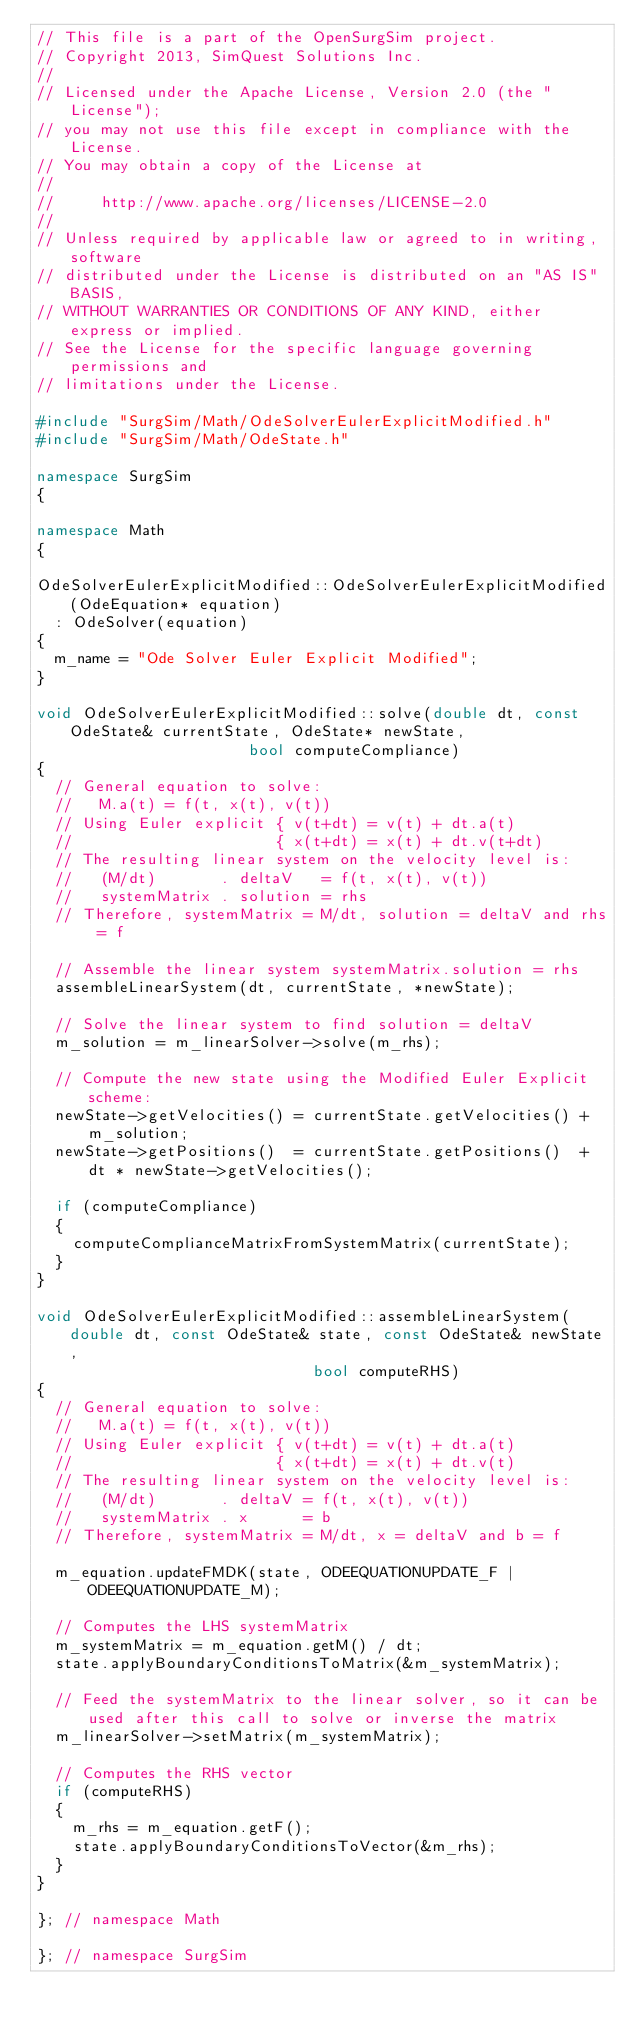<code> <loc_0><loc_0><loc_500><loc_500><_C++_>// This file is a part of the OpenSurgSim project.
// Copyright 2013, SimQuest Solutions Inc.
//
// Licensed under the Apache License, Version 2.0 (the "License");
// you may not use this file except in compliance with the License.
// You may obtain a copy of the License at
//
//     http://www.apache.org/licenses/LICENSE-2.0
//
// Unless required by applicable law or agreed to in writing, software
// distributed under the License is distributed on an "AS IS" BASIS,
// WITHOUT WARRANTIES OR CONDITIONS OF ANY KIND, either express or implied.
// See the License for the specific language governing permissions and
// limitations under the License.

#include "SurgSim/Math/OdeSolverEulerExplicitModified.h"
#include "SurgSim/Math/OdeState.h"

namespace SurgSim
{

namespace Math
{

OdeSolverEulerExplicitModified::OdeSolverEulerExplicitModified(OdeEquation* equation)
	: OdeSolver(equation)
{
	m_name = "Ode Solver Euler Explicit Modified";
}

void OdeSolverEulerExplicitModified::solve(double dt, const OdeState& currentState, OdeState* newState,
										   bool computeCompliance)
{
	// General equation to solve:
	//   M.a(t) = f(t, x(t), v(t))
	// Using Euler explicit { v(t+dt) = v(t) + dt.a(t)
	//                      { x(t+dt) = x(t) + dt.v(t+dt)
	// The resulting linear system on the velocity level is:
	//   (M/dt)       . deltaV   = f(t, x(t), v(t))
	//   systemMatrix . solution = rhs
	// Therefore, systemMatrix = M/dt, solution = deltaV and rhs = f

	// Assemble the linear system systemMatrix.solution = rhs
	assembleLinearSystem(dt, currentState, *newState);

	// Solve the linear system to find solution = deltaV
	m_solution = m_linearSolver->solve(m_rhs);

	// Compute the new state using the Modified Euler Explicit scheme:
	newState->getVelocities() = currentState.getVelocities() + m_solution;
	newState->getPositions()  = currentState.getPositions()  + dt * newState->getVelocities();

	if (computeCompliance)
	{
		computeComplianceMatrixFromSystemMatrix(currentState);
	}
}

void OdeSolverEulerExplicitModified::assembleLinearSystem(double dt, const OdeState& state, const OdeState& newState,
														  bool computeRHS)
{
	// General equation to solve:
	//   M.a(t) = f(t, x(t), v(t))
	// Using Euler explicit { v(t+dt) = v(t) + dt.a(t)
	//                      { x(t+dt) = x(t) + dt.v(t)
	// The resulting linear system on the velocity level is:
	//   (M/dt)       . deltaV = f(t, x(t), v(t))
	//   systemMatrix . x      = b
	// Therefore, systemMatrix = M/dt, x = deltaV and b = f

	m_equation.updateFMDK(state, ODEEQUATIONUPDATE_F | ODEEQUATIONUPDATE_M);

	// Computes the LHS systemMatrix
	m_systemMatrix = m_equation.getM() / dt;
	state.applyBoundaryConditionsToMatrix(&m_systemMatrix);

	// Feed the systemMatrix to the linear solver, so it can be used after this call to solve or inverse the matrix
	m_linearSolver->setMatrix(m_systemMatrix);

	// Computes the RHS vector
	if (computeRHS)
	{
		m_rhs = m_equation.getF();
		state.applyBoundaryConditionsToVector(&m_rhs);
	}
}

}; // namespace Math

}; // namespace SurgSim
</code> 